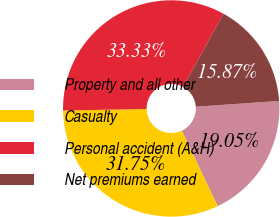Convert chart to OTSL. <chart><loc_0><loc_0><loc_500><loc_500><pie_chart><fcel>Property and all other<fcel>Casualty<fcel>Personal accident (A&H)<fcel>Net premiums earned<nl><fcel>19.05%<fcel>31.75%<fcel>33.33%<fcel>15.87%<nl></chart> 